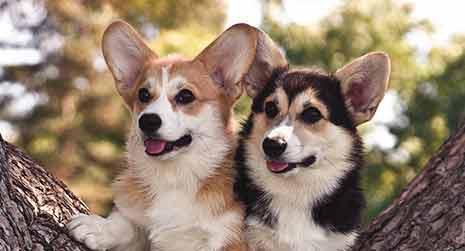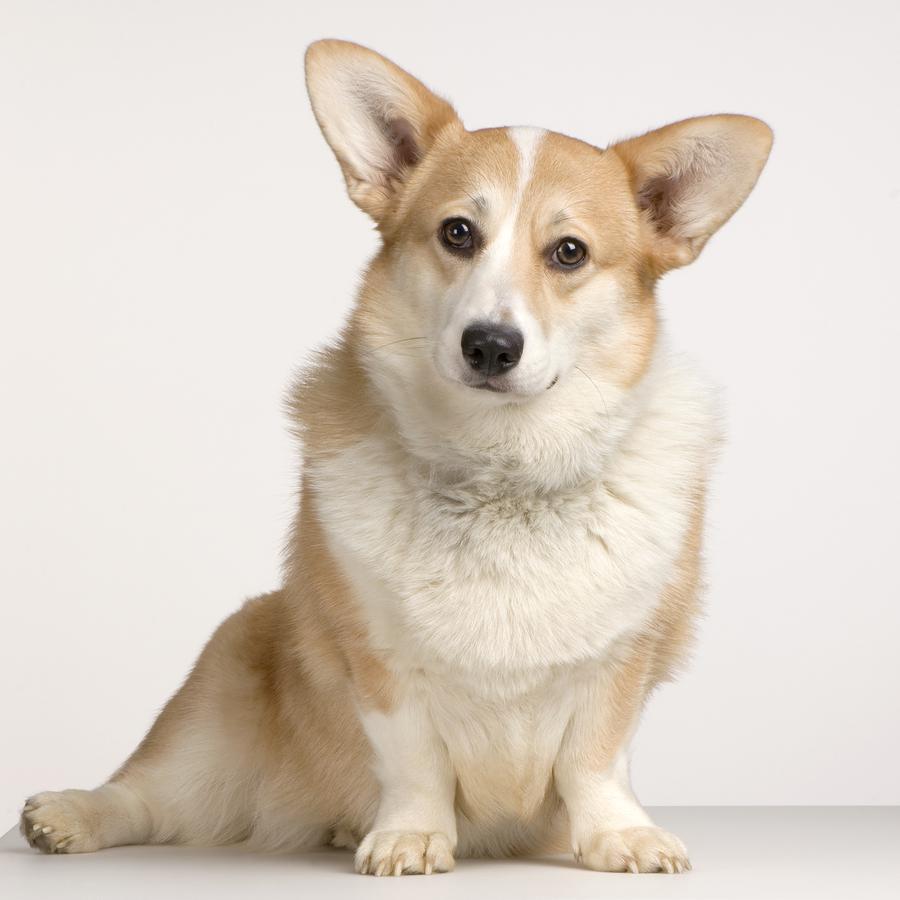The first image is the image on the left, the second image is the image on the right. Assess this claim about the two images: "All dogs are looking in the general direction of the camera.". Correct or not? Answer yes or no. Yes. The first image is the image on the left, the second image is the image on the right. Given the left and right images, does the statement "The image on the right has a one dog with its tongue showing." hold true? Answer yes or no. No. 